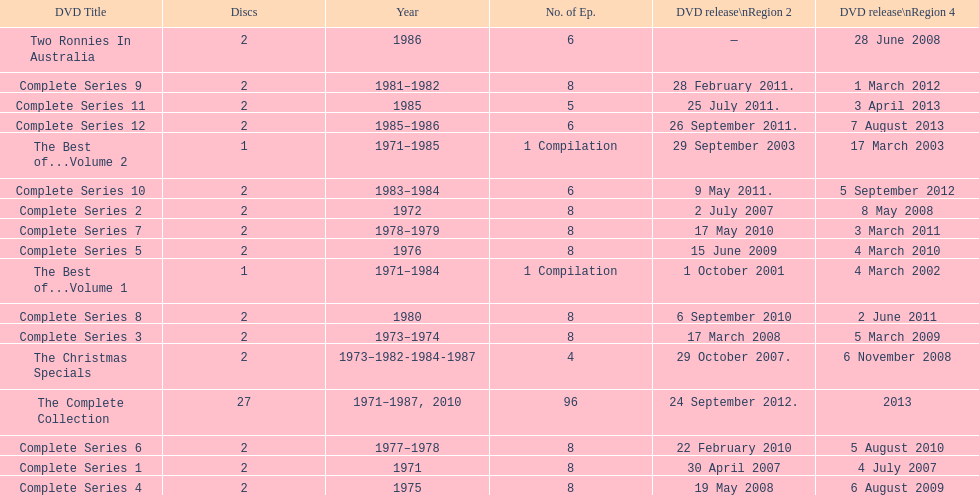What is previous to complete series 10? Complete Series 9. 